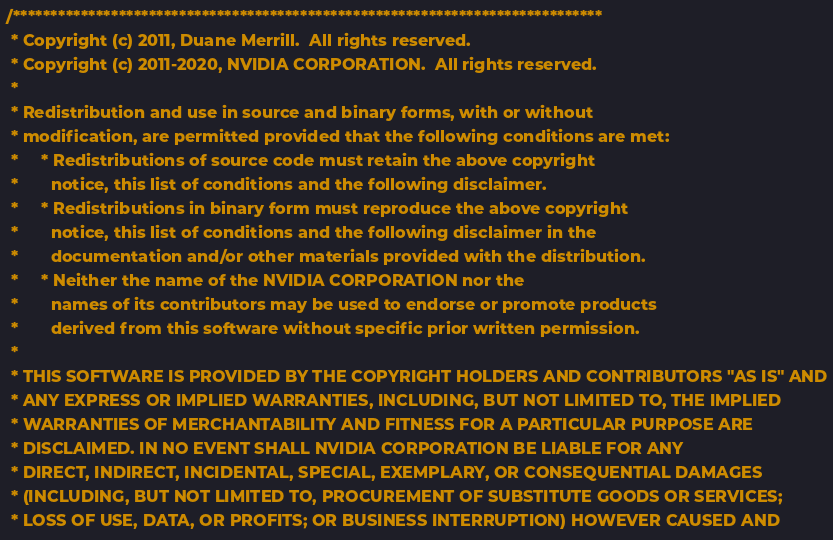Convert code to text. <code><loc_0><loc_0><loc_500><loc_500><_Cuda_>/******************************************************************************
 * Copyright (c) 2011, Duane Merrill.  All rights reserved.
 * Copyright (c) 2011-2020, NVIDIA CORPORATION.  All rights reserved.
 *
 * Redistribution and use in source and binary forms, with or without
 * modification, are permitted provided that the following conditions are met:
 *     * Redistributions of source code must retain the above copyright
 *       notice, this list of conditions and the following disclaimer.
 *     * Redistributions in binary form must reproduce the above copyright
 *       notice, this list of conditions and the following disclaimer in the
 *       documentation and/or other materials provided with the distribution.
 *     * Neither the name of the NVIDIA CORPORATION nor the
 *       names of its contributors may be used to endorse or promote products
 *       derived from this software without specific prior written permission.
 *
 * THIS SOFTWARE IS PROVIDED BY THE COPYRIGHT HOLDERS AND CONTRIBUTORS "AS IS" AND
 * ANY EXPRESS OR IMPLIED WARRANTIES, INCLUDING, BUT NOT LIMITED TO, THE IMPLIED
 * WARRANTIES OF MERCHANTABILITY AND FITNESS FOR A PARTICULAR PURPOSE ARE
 * DISCLAIMED. IN NO EVENT SHALL NVIDIA CORPORATION BE LIABLE FOR ANY
 * DIRECT, INDIRECT, INCIDENTAL, SPECIAL, EXEMPLARY, OR CONSEQUENTIAL DAMAGES
 * (INCLUDING, BUT NOT LIMITED TO, PROCUREMENT OF SUBSTITUTE GOODS OR SERVICES;
 * LOSS OF USE, DATA, OR PROFITS; OR BUSINESS INTERRUPTION) HOWEVER CAUSED AND</code> 